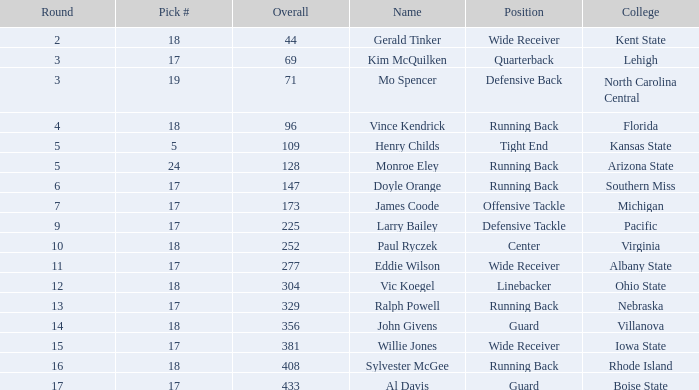Name the total number of round for wide receiver for kent state 1.0. 